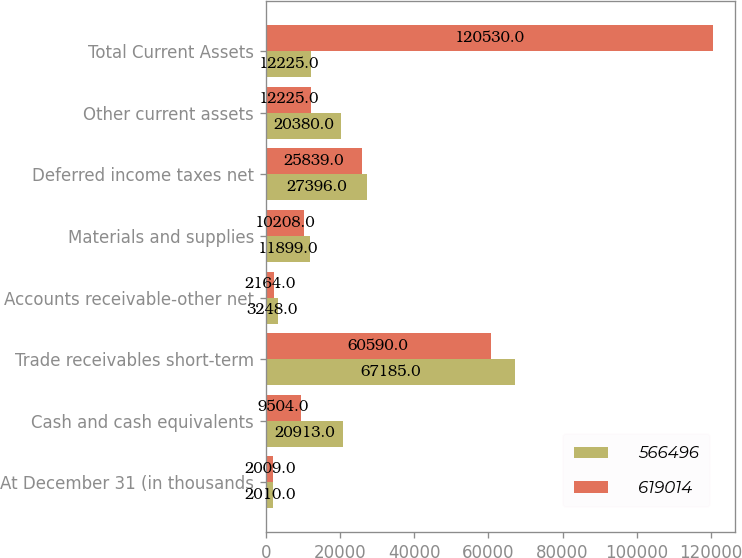Convert chart. <chart><loc_0><loc_0><loc_500><loc_500><stacked_bar_chart><ecel><fcel>At December 31 (in thousands<fcel>Cash and cash equivalents<fcel>Trade receivables short-term<fcel>Accounts receivable-other net<fcel>Materials and supplies<fcel>Deferred income taxes net<fcel>Other current assets<fcel>Total Current Assets<nl><fcel>566496<fcel>2010<fcel>20913<fcel>67185<fcel>3248<fcel>11899<fcel>27396<fcel>20380<fcel>12225<nl><fcel>619014<fcel>2009<fcel>9504<fcel>60590<fcel>2164<fcel>10208<fcel>25839<fcel>12225<fcel>120530<nl></chart> 